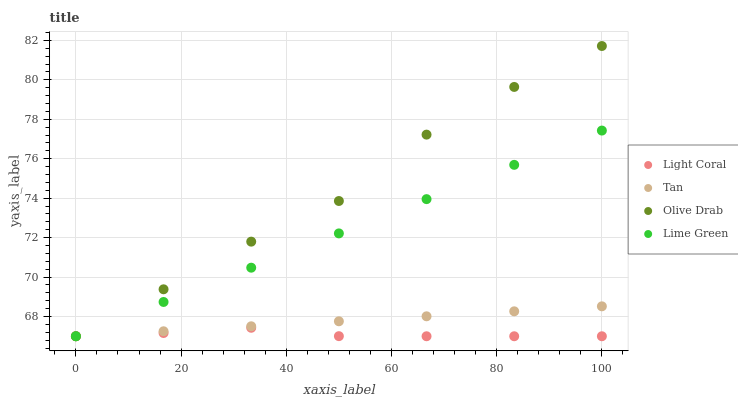Does Light Coral have the minimum area under the curve?
Answer yes or no. Yes. Does Olive Drab have the maximum area under the curve?
Answer yes or no. Yes. Does Tan have the minimum area under the curve?
Answer yes or no. No. Does Tan have the maximum area under the curve?
Answer yes or no. No. Is Lime Green the smoothest?
Answer yes or no. Yes. Is Olive Drab the roughest?
Answer yes or no. Yes. Is Tan the smoothest?
Answer yes or no. No. Is Tan the roughest?
Answer yes or no. No. Does Light Coral have the lowest value?
Answer yes or no. Yes. Does Olive Drab have the highest value?
Answer yes or no. Yes. Does Tan have the highest value?
Answer yes or no. No. Does Olive Drab intersect Light Coral?
Answer yes or no. Yes. Is Olive Drab less than Light Coral?
Answer yes or no. No. Is Olive Drab greater than Light Coral?
Answer yes or no. No. 